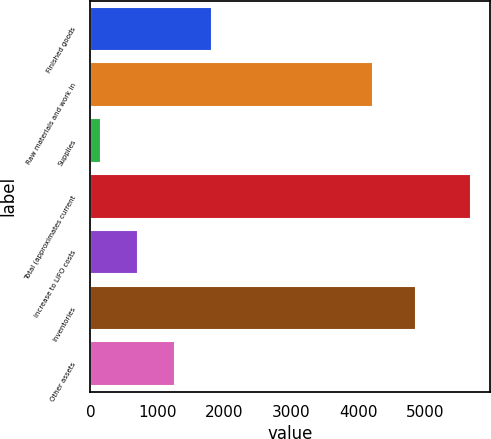Convert chart. <chart><loc_0><loc_0><loc_500><loc_500><bar_chart><fcel>Finished goods<fcel>Raw materials and work in<fcel>Supplies<fcel>Total (approximates current<fcel>Increase to LIFO costs<fcel>Inventories<fcel>Other assets<nl><fcel>1812.8<fcel>4222<fcel>155<fcel>5681<fcel>707.6<fcel>4866<fcel>1260.2<nl></chart> 